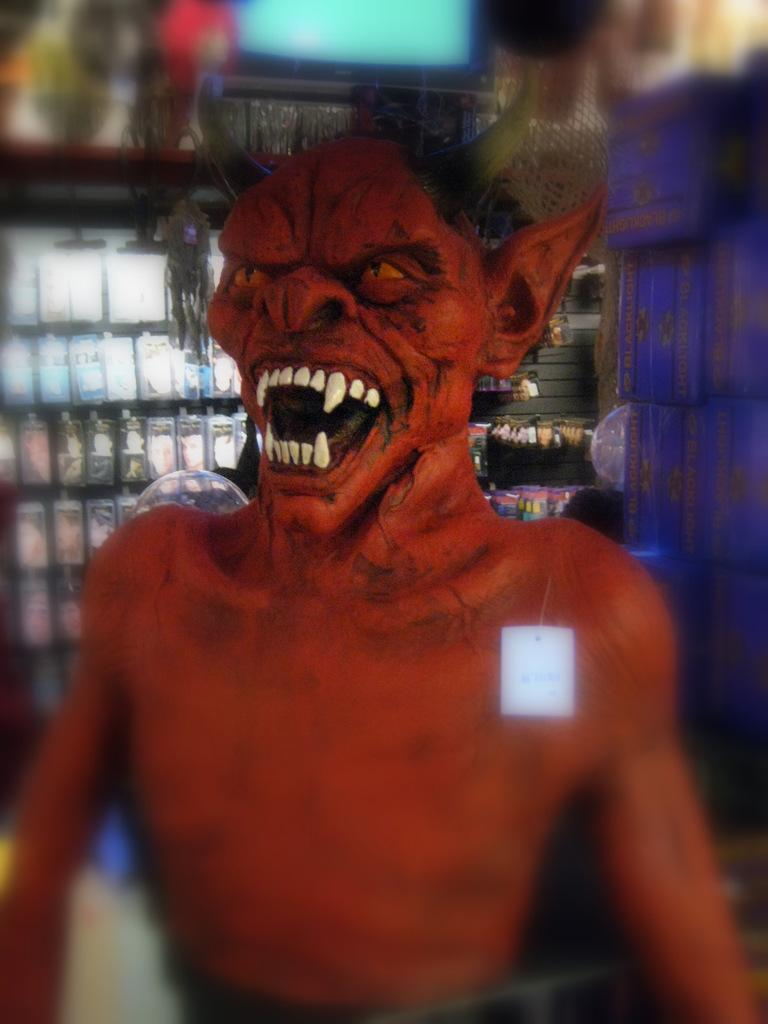What type of toy can be seen in the image? There is a brown toy in the image. What electronic device is visible in the image? There is a television visible in the image. Where are the articles stored in the image? The articles are stored in a cupboard in the image. What songs are being played on the board in the image? There is no board or songs present in the image. What is the desire of the toy in the image? The toy in the image is an inanimate object and does not have desires. 